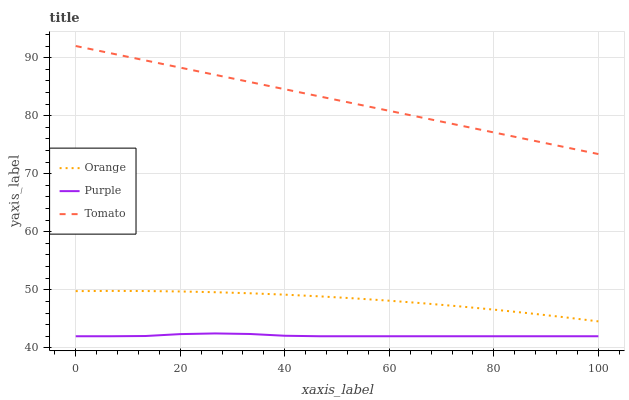Does Tomato have the minimum area under the curve?
Answer yes or no. No. Does Purple have the maximum area under the curve?
Answer yes or no. No. Is Purple the smoothest?
Answer yes or no. No. Is Tomato the roughest?
Answer yes or no. No. Does Tomato have the lowest value?
Answer yes or no. No. Does Purple have the highest value?
Answer yes or no. No. Is Purple less than Tomato?
Answer yes or no. Yes. Is Tomato greater than Orange?
Answer yes or no. Yes. Does Purple intersect Tomato?
Answer yes or no. No. 